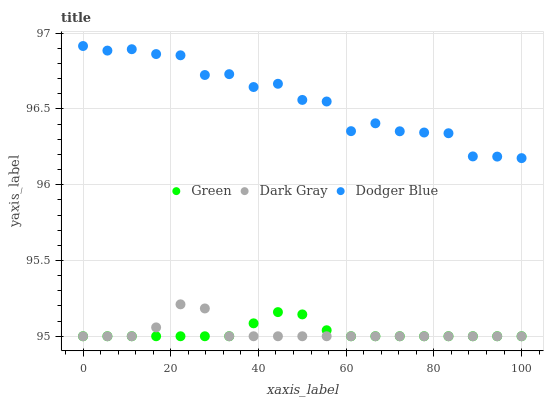Does Green have the minimum area under the curve?
Answer yes or no. Yes. Does Dodger Blue have the maximum area under the curve?
Answer yes or no. Yes. Does Dodger Blue have the minimum area under the curve?
Answer yes or no. No. Does Green have the maximum area under the curve?
Answer yes or no. No. Is Green the smoothest?
Answer yes or no. Yes. Is Dodger Blue the roughest?
Answer yes or no. Yes. Is Dodger Blue the smoothest?
Answer yes or no. No. Is Green the roughest?
Answer yes or no. No. Does Dark Gray have the lowest value?
Answer yes or no. Yes. Does Dodger Blue have the lowest value?
Answer yes or no. No. Does Dodger Blue have the highest value?
Answer yes or no. Yes. Does Green have the highest value?
Answer yes or no. No. Is Green less than Dodger Blue?
Answer yes or no. Yes. Is Dodger Blue greater than Dark Gray?
Answer yes or no. Yes. Does Green intersect Dark Gray?
Answer yes or no. Yes. Is Green less than Dark Gray?
Answer yes or no. No. Is Green greater than Dark Gray?
Answer yes or no. No. Does Green intersect Dodger Blue?
Answer yes or no. No. 